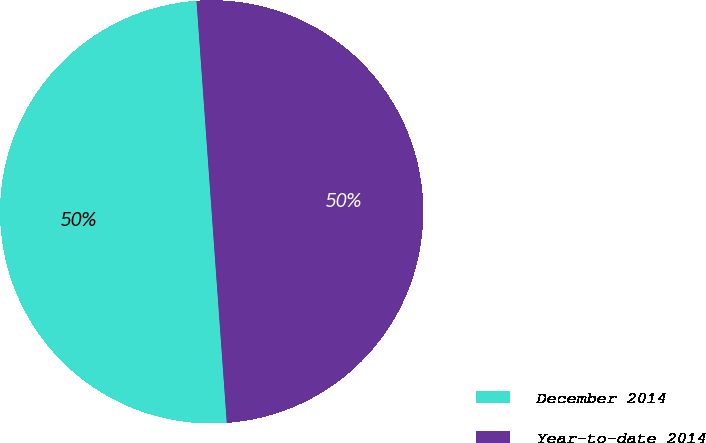Convert chart to OTSL. <chart><loc_0><loc_0><loc_500><loc_500><pie_chart><fcel>December 2014<fcel>Year-to-date 2014<nl><fcel>50.0%<fcel>50.0%<nl></chart> 